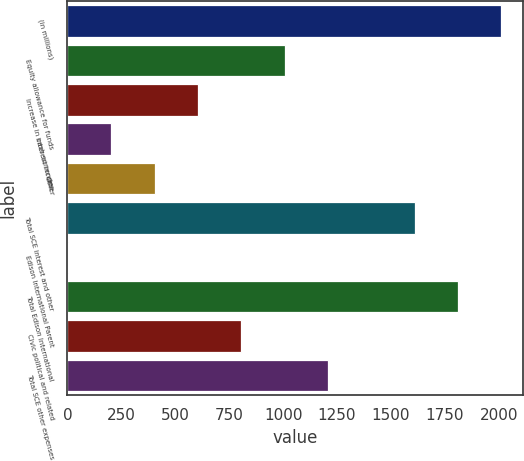Convert chart to OTSL. <chart><loc_0><loc_0><loc_500><loc_500><bar_chart><fcel>(in millions)<fcel>Equity allowance for funds<fcel>Increase in cash surrender<fcel>Interest income<fcel>Other<fcel>Total SCE interest and other<fcel>Edison International Parent<fcel>Total Edison International<fcel>Civic political and related<fcel>Total SCE other expenses<nl><fcel>2013<fcel>1007.5<fcel>605.3<fcel>203.1<fcel>404.2<fcel>1610.8<fcel>2<fcel>1811.9<fcel>806.4<fcel>1208.6<nl></chart> 